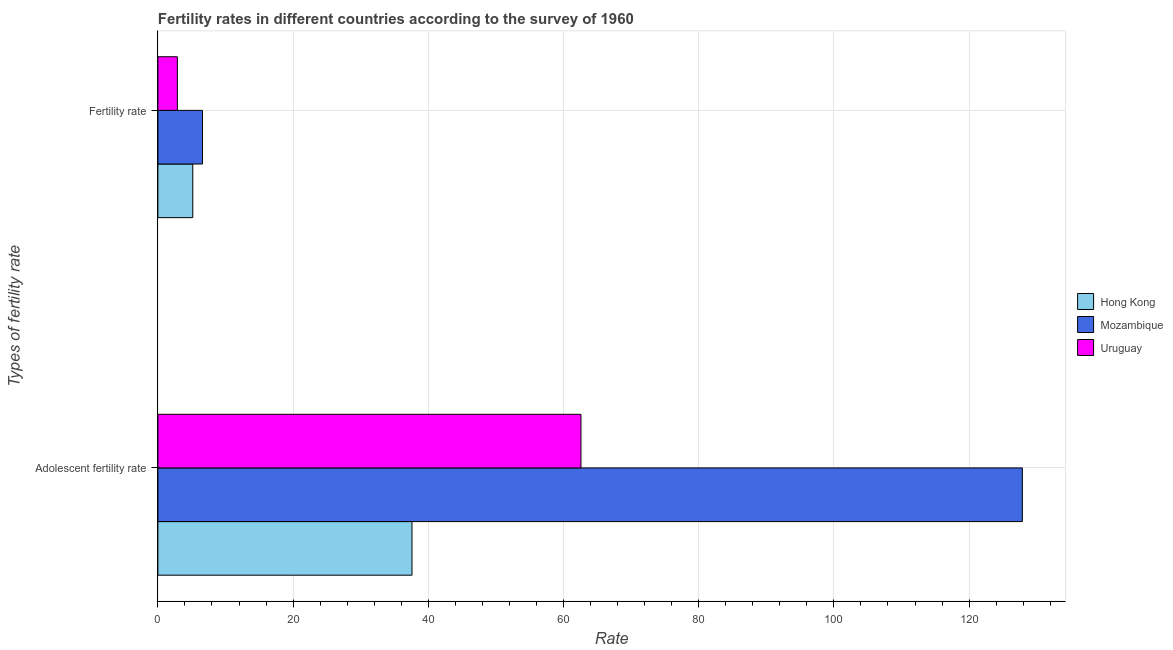How many different coloured bars are there?
Provide a succinct answer. 3. How many groups of bars are there?
Offer a terse response. 2. Are the number of bars on each tick of the Y-axis equal?
Make the answer very short. Yes. How many bars are there on the 1st tick from the top?
Your answer should be very brief. 3. How many bars are there on the 2nd tick from the bottom?
Your response must be concise. 3. What is the label of the 1st group of bars from the top?
Your response must be concise. Fertility rate. What is the fertility rate in Hong Kong?
Make the answer very short. 5.16. Across all countries, what is the maximum fertility rate?
Ensure brevity in your answer.  6.6. Across all countries, what is the minimum adolescent fertility rate?
Provide a short and direct response. 37.59. In which country was the fertility rate maximum?
Your response must be concise. Mozambique. In which country was the fertility rate minimum?
Make the answer very short. Uruguay. What is the total adolescent fertility rate in the graph?
Provide a succinct answer. 228.05. What is the difference between the adolescent fertility rate in Uruguay and that in Mozambique?
Keep it short and to the point. -65.29. What is the difference between the adolescent fertility rate in Mozambique and the fertility rate in Uruguay?
Offer a very short reply. 125. What is the average fertility rate per country?
Offer a very short reply. 4.88. What is the difference between the fertility rate and adolescent fertility rate in Mozambique?
Provide a short and direct response. -121.28. In how many countries, is the fertility rate greater than 20 ?
Make the answer very short. 0. What is the ratio of the fertility rate in Uruguay to that in Hong Kong?
Your answer should be compact. 0.56. In how many countries, is the fertility rate greater than the average fertility rate taken over all countries?
Your answer should be very brief. 2. What does the 3rd bar from the top in Fertility rate represents?
Provide a succinct answer. Hong Kong. What does the 2nd bar from the bottom in Adolescent fertility rate represents?
Your response must be concise. Mozambique. How many countries are there in the graph?
Make the answer very short. 3. What is the difference between two consecutive major ticks on the X-axis?
Ensure brevity in your answer.  20. Are the values on the major ticks of X-axis written in scientific E-notation?
Provide a succinct answer. No. Does the graph contain grids?
Your response must be concise. Yes. Where does the legend appear in the graph?
Your answer should be compact. Center right. How are the legend labels stacked?
Provide a succinct answer. Vertical. What is the title of the graph?
Make the answer very short. Fertility rates in different countries according to the survey of 1960. What is the label or title of the X-axis?
Your answer should be compact. Rate. What is the label or title of the Y-axis?
Ensure brevity in your answer.  Types of fertility rate. What is the Rate in Hong Kong in Adolescent fertility rate?
Your answer should be very brief. 37.59. What is the Rate of Mozambique in Adolescent fertility rate?
Keep it short and to the point. 127.88. What is the Rate of Uruguay in Adolescent fertility rate?
Your answer should be very brief. 62.59. What is the Rate in Hong Kong in Fertility rate?
Provide a short and direct response. 5.16. What is the Rate of Uruguay in Fertility rate?
Offer a terse response. 2.88. Across all Types of fertility rate, what is the maximum Rate in Hong Kong?
Offer a very short reply. 37.59. Across all Types of fertility rate, what is the maximum Rate in Mozambique?
Offer a terse response. 127.88. Across all Types of fertility rate, what is the maximum Rate of Uruguay?
Your response must be concise. 62.59. Across all Types of fertility rate, what is the minimum Rate in Hong Kong?
Make the answer very short. 5.16. Across all Types of fertility rate, what is the minimum Rate in Uruguay?
Make the answer very short. 2.88. What is the total Rate in Hong Kong in the graph?
Ensure brevity in your answer.  42.75. What is the total Rate of Mozambique in the graph?
Offer a terse response. 134.48. What is the total Rate of Uruguay in the graph?
Your answer should be very brief. 65.47. What is the difference between the Rate in Hong Kong in Adolescent fertility rate and that in Fertility rate?
Provide a short and direct response. 32.43. What is the difference between the Rate in Mozambique in Adolescent fertility rate and that in Fertility rate?
Provide a succinct answer. 121.28. What is the difference between the Rate in Uruguay in Adolescent fertility rate and that in Fertility rate?
Your answer should be very brief. 59.71. What is the difference between the Rate of Hong Kong in Adolescent fertility rate and the Rate of Mozambique in Fertility rate?
Your answer should be very brief. 30.99. What is the difference between the Rate in Hong Kong in Adolescent fertility rate and the Rate in Uruguay in Fertility rate?
Keep it short and to the point. 34.71. What is the difference between the Rate of Mozambique in Adolescent fertility rate and the Rate of Uruguay in Fertility rate?
Provide a short and direct response. 125. What is the average Rate of Hong Kong per Types of fertility rate?
Provide a short and direct response. 21.37. What is the average Rate of Mozambique per Types of fertility rate?
Keep it short and to the point. 67.24. What is the average Rate of Uruguay per Types of fertility rate?
Make the answer very short. 32.73. What is the difference between the Rate in Hong Kong and Rate in Mozambique in Adolescent fertility rate?
Offer a very short reply. -90.29. What is the difference between the Rate of Hong Kong and Rate of Uruguay in Adolescent fertility rate?
Provide a short and direct response. -25. What is the difference between the Rate in Mozambique and Rate in Uruguay in Adolescent fertility rate?
Keep it short and to the point. 65.29. What is the difference between the Rate of Hong Kong and Rate of Mozambique in Fertility rate?
Your answer should be very brief. -1.44. What is the difference between the Rate of Hong Kong and Rate of Uruguay in Fertility rate?
Your answer should be very brief. 2.28. What is the difference between the Rate in Mozambique and Rate in Uruguay in Fertility rate?
Your response must be concise. 3.72. What is the ratio of the Rate in Hong Kong in Adolescent fertility rate to that in Fertility rate?
Make the answer very short. 7.28. What is the ratio of the Rate in Mozambique in Adolescent fertility rate to that in Fertility rate?
Make the answer very short. 19.38. What is the ratio of the Rate of Uruguay in Adolescent fertility rate to that in Fertility rate?
Ensure brevity in your answer.  21.73. What is the difference between the highest and the second highest Rate in Hong Kong?
Make the answer very short. 32.43. What is the difference between the highest and the second highest Rate of Mozambique?
Your response must be concise. 121.28. What is the difference between the highest and the second highest Rate of Uruguay?
Ensure brevity in your answer.  59.71. What is the difference between the highest and the lowest Rate in Hong Kong?
Your answer should be very brief. 32.43. What is the difference between the highest and the lowest Rate of Mozambique?
Provide a short and direct response. 121.28. What is the difference between the highest and the lowest Rate in Uruguay?
Keep it short and to the point. 59.71. 